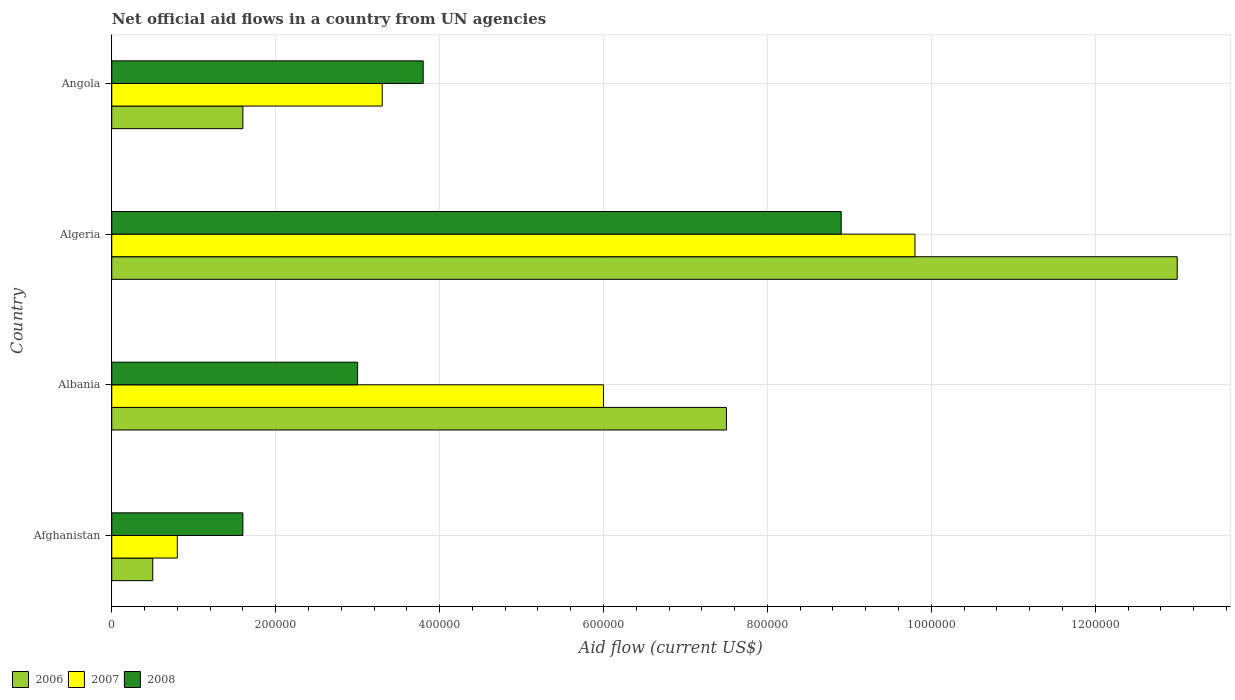How many bars are there on the 4th tick from the bottom?
Your response must be concise. 3. What is the label of the 2nd group of bars from the top?
Offer a very short reply. Algeria. What is the net official aid flow in 2007 in Afghanistan?
Keep it short and to the point. 8.00e+04. Across all countries, what is the maximum net official aid flow in 2006?
Offer a very short reply. 1.30e+06. In which country was the net official aid flow in 2008 maximum?
Provide a short and direct response. Algeria. In which country was the net official aid flow in 2006 minimum?
Offer a terse response. Afghanistan. What is the total net official aid flow in 2007 in the graph?
Provide a succinct answer. 1.99e+06. What is the difference between the net official aid flow in 2008 in Afghanistan and that in Albania?
Keep it short and to the point. -1.40e+05. What is the average net official aid flow in 2007 per country?
Offer a terse response. 4.98e+05. What is the ratio of the net official aid flow in 2008 in Albania to that in Algeria?
Make the answer very short. 0.34. Is the difference between the net official aid flow in 2007 in Albania and Algeria greater than the difference between the net official aid flow in 2006 in Albania and Algeria?
Give a very brief answer. Yes. What is the difference between the highest and the second highest net official aid flow in 2008?
Keep it short and to the point. 5.10e+05. What is the difference between the highest and the lowest net official aid flow in 2006?
Offer a very short reply. 1.25e+06. In how many countries, is the net official aid flow in 2008 greater than the average net official aid flow in 2008 taken over all countries?
Your response must be concise. 1. What does the 3rd bar from the top in Angola represents?
Ensure brevity in your answer.  2006. Is it the case that in every country, the sum of the net official aid flow in 2007 and net official aid flow in 2008 is greater than the net official aid flow in 2006?
Offer a very short reply. Yes. How many countries are there in the graph?
Your answer should be compact. 4. Are the values on the major ticks of X-axis written in scientific E-notation?
Ensure brevity in your answer.  No. Does the graph contain grids?
Offer a very short reply. Yes. Where does the legend appear in the graph?
Ensure brevity in your answer.  Bottom left. How many legend labels are there?
Ensure brevity in your answer.  3. How are the legend labels stacked?
Offer a terse response. Horizontal. What is the title of the graph?
Offer a very short reply. Net official aid flows in a country from UN agencies. Does "1996" appear as one of the legend labels in the graph?
Provide a short and direct response. No. What is the label or title of the X-axis?
Give a very brief answer. Aid flow (current US$). What is the Aid flow (current US$) in 2007 in Afghanistan?
Ensure brevity in your answer.  8.00e+04. What is the Aid flow (current US$) in 2008 in Afghanistan?
Offer a terse response. 1.60e+05. What is the Aid flow (current US$) of 2006 in Albania?
Provide a succinct answer. 7.50e+05. What is the Aid flow (current US$) of 2007 in Albania?
Give a very brief answer. 6.00e+05. What is the Aid flow (current US$) in 2008 in Albania?
Ensure brevity in your answer.  3.00e+05. What is the Aid flow (current US$) in 2006 in Algeria?
Offer a terse response. 1.30e+06. What is the Aid flow (current US$) in 2007 in Algeria?
Offer a very short reply. 9.80e+05. What is the Aid flow (current US$) of 2008 in Algeria?
Your response must be concise. 8.90e+05. What is the Aid flow (current US$) in 2006 in Angola?
Make the answer very short. 1.60e+05. What is the Aid flow (current US$) in 2007 in Angola?
Ensure brevity in your answer.  3.30e+05. Across all countries, what is the maximum Aid flow (current US$) in 2006?
Keep it short and to the point. 1.30e+06. Across all countries, what is the maximum Aid flow (current US$) in 2007?
Offer a very short reply. 9.80e+05. Across all countries, what is the maximum Aid flow (current US$) of 2008?
Make the answer very short. 8.90e+05. What is the total Aid flow (current US$) of 2006 in the graph?
Your answer should be very brief. 2.26e+06. What is the total Aid flow (current US$) in 2007 in the graph?
Offer a terse response. 1.99e+06. What is the total Aid flow (current US$) in 2008 in the graph?
Make the answer very short. 1.73e+06. What is the difference between the Aid flow (current US$) in 2006 in Afghanistan and that in Albania?
Your answer should be compact. -7.00e+05. What is the difference between the Aid flow (current US$) in 2007 in Afghanistan and that in Albania?
Your answer should be compact. -5.20e+05. What is the difference between the Aid flow (current US$) of 2008 in Afghanistan and that in Albania?
Provide a short and direct response. -1.40e+05. What is the difference between the Aid flow (current US$) of 2006 in Afghanistan and that in Algeria?
Offer a terse response. -1.25e+06. What is the difference between the Aid flow (current US$) in 2007 in Afghanistan and that in Algeria?
Keep it short and to the point. -9.00e+05. What is the difference between the Aid flow (current US$) in 2008 in Afghanistan and that in Algeria?
Provide a short and direct response. -7.30e+05. What is the difference between the Aid flow (current US$) in 2006 in Afghanistan and that in Angola?
Provide a short and direct response. -1.10e+05. What is the difference between the Aid flow (current US$) of 2006 in Albania and that in Algeria?
Your response must be concise. -5.50e+05. What is the difference between the Aid flow (current US$) in 2007 in Albania and that in Algeria?
Your answer should be very brief. -3.80e+05. What is the difference between the Aid flow (current US$) in 2008 in Albania and that in Algeria?
Give a very brief answer. -5.90e+05. What is the difference between the Aid flow (current US$) of 2006 in Albania and that in Angola?
Your answer should be compact. 5.90e+05. What is the difference between the Aid flow (current US$) in 2007 in Albania and that in Angola?
Make the answer very short. 2.70e+05. What is the difference between the Aid flow (current US$) of 2006 in Algeria and that in Angola?
Your response must be concise. 1.14e+06. What is the difference between the Aid flow (current US$) of 2007 in Algeria and that in Angola?
Ensure brevity in your answer.  6.50e+05. What is the difference between the Aid flow (current US$) of 2008 in Algeria and that in Angola?
Offer a terse response. 5.10e+05. What is the difference between the Aid flow (current US$) of 2006 in Afghanistan and the Aid flow (current US$) of 2007 in Albania?
Your response must be concise. -5.50e+05. What is the difference between the Aid flow (current US$) in 2007 in Afghanistan and the Aid flow (current US$) in 2008 in Albania?
Provide a short and direct response. -2.20e+05. What is the difference between the Aid flow (current US$) in 2006 in Afghanistan and the Aid flow (current US$) in 2007 in Algeria?
Give a very brief answer. -9.30e+05. What is the difference between the Aid flow (current US$) in 2006 in Afghanistan and the Aid flow (current US$) in 2008 in Algeria?
Ensure brevity in your answer.  -8.40e+05. What is the difference between the Aid flow (current US$) in 2007 in Afghanistan and the Aid flow (current US$) in 2008 in Algeria?
Make the answer very short. -8.10e+05. What is the difference between the Aid flow (current US$) of 2006 in Afghanistan and the Aid flow (current US$) of 2007 in Angola?
Give a very brief answer. -2.80e+05. What is the difference between the Aid flow (current US$) of 2006 in Afghanistan and the Aid flow (current US$) of 2008 in Angola?
Give a very brief answer. -3.30e+05. What is the difference between the Aid flow (current US$) in 2006 in Albania and the Aid flow (current US$) in 2008 in Algeria?
Your answer should be compact. -1.40e+05. What is the difference between the Aid flow (current US$) in 2007 in Albania and the Aid flow (current US$) in 2008 in Algeria?
Offer a very short reply. -2.90e+05. What is the difference between the Aid flow (current US$) of 2006 in Albania and the Aid flow (current US$) of 2008 in Angola?
Provide a short and direct response. 3.70e+05. What is the difference between the Aid flow (current US$) in 2007 in Albania and the Aid flow (current US$) in 2008 in Angola?
Provide a short and direct response. 2.20e+05. What is the difference between the Aid flow (current US$) in 2006 in Algeria and the Aid flow (current US$) in 2007 in Angola?
Offer a very short reply. 9.70e+05. What is the difference between the Aid flow (current US$) of 2006 in Algeria and the Aid flow (current US$) of 2008 in Angola?
Give a very brief answer. 9.20e+05. What is the difference between the Aid flow (current US$) in 2007 in Algeria and the Aid flow (current US$) in 2008 in Angola?
Offer a very short reply. 6.00e+05. What is the average Aid flow (current US$) in 2006 per country?
Offer a terse response. 5.65e+05. What is the average Aid flow (current US$) of 2007 per country?
Your answer should be compact. 4.98e+05. What is the average Aid flow (current US$) in 2008 per country?
Give a very brief answer. 4.32e+05. What is the difference between the Aid flow (current US$) of 2006 and Aid flow (current US$) of 2007 in Afghanistan?
Your response must be concise. -3.00e+04. What is the difference between the Aid flow (current US$) of 2006 and Aid flow (current US$) of 2008 in Afghanistan?
Offer a very short reply. -1.10e+05. What is the difference between the Aid flow (current US$) in 2006 and Aid flow (current US$) in 2007 in Albania?
Your response must be concise. 1.50e+05. What is the difference between the Aid flow (current US$) in 2006 and Aid flow (current US$) in 2008 in Albania?
Provide a succinct answer. 4.50e+05. What is the difference between the Aid flow (current US$) of 2006 and Aid flow (current US$) of 2007 in Algeria?
Offer a terse response. 3.20e+05. What is the difference between the Aid flow (current US$) of 2006 and Aid flow (current US$) of 2008 in Algeria?
Your response must be concise. 4.10e+05. What is the difference between the Aid flow (current US$) in 2006 and Aid flow (current US$) in 2008 in Angola?
Your answer should be very brief. -2.20e+05. What is the difference between the Aid flow (current US$) in 2007 and Aid flow (current US$) in 2008 in Angola?
Offer a very short reply. -5.00e+04. What is the ratio of the Aid flow (current US$) of 2006 in Afghanistan to that in Albania?
Your answer should be compact. 0.07. What is the ratio of the Aid flow (current US$) of 2007 in Afghanistan to that in Albania?
Your answer should be very brief. 0.13. What is the ratio of the Aid flow (current US$) of 2008 in Afghanistan to that in Albania?
Keep it short and to the point. 0.53. What is the ratio of the Aid flow (current US$) in 2006 in Afghanistan to that in Algeria?
Your response must be concise. 0.04. What is the ratio of the Aid flow (current US$) of 2007 in Afghanistan to that in Algeria?
Give a very brief answer. 0.08. What is the ratio of the Aid flow (current US$) in 2008 in Afghanistan to that in Algeria?
Your answer should be compact. 0.18. What is the ratio of the Aid flow (current US$) in 2006 in Afghanistan to that in Angola?
Ensure brevity in your answer.  0.31. What is the ratio of the Aid flow (current US$) of 2007 in Afghanistan to that in Angola?
Offer a terse response. 0.24. What is the ratio of the Aid flow (current US$) in 2008 in Afghanistan to that in Angola?
Your answer should be very brief. 0.42. What is the ratio of the Aid flow (current US$) of 2006 in Albania to that in Algeria?
Your answer should be compact. 0.58. What is the ratio of the Aid flow (current US$) in 2007 in Albania to that in Algeria?
Your answer should be compact. 0.61. What is the ratio of the Aid flow (current US$) in 2008 in Albania to that in Algeria?
Offer a very short reply. 0.34. What is the ratio of the Aid flow (current US$) in 2006 in Albania to that in Angola?
Provide a succinct answer. 4.69. What is the ratio of the Aid flow (current US$) in 2007 in Albania to that in Angola?
Your response must be concise. 1.82. What is the ratio of the Aid flow (current US$) in 2008 in Albania to that in Angola?
Ensure brevity in your answer.  0.79. What is the ratio of the Aid flow (current US$) of 2006 in Algeria to that in Angola?
Make the answer very short. 8.12. What is the ratio of the Aid flow (current US$) in 2007 in Algeria to that in Angola?
Offer a very short reply. 2.97. What is the ratio of the Aid flow (current US$) in 2008 in Algeria to that in Angola?
Make the answer very short. 2.34. What is the difference between the highest and the second highest Aid flow (current US$) of 2006?
Make the answer very short. 5.50e+05. What is the difference between the highest and the second highest Aid flow (current US$) in 2007?
Your answer should be compact. 3.80e+05. What is the difference between the highest and the second highest Aid flow (current US$) in 2008?
Offer a terse response. 5.10e+05. What is the difference between the highest and the lowest Aid flow (current US$) of 2006?
Ensure brevity in your answer.  1.25e+06. What is the difference between the highest and the lowest Aid flow (current US$) of 2007?
Your answer should be compact. 9.00e+05. What is the difference between the highest and the lowest Aid flow (current US$) in 2008?
Offer a terse response. 7.30e+05. 